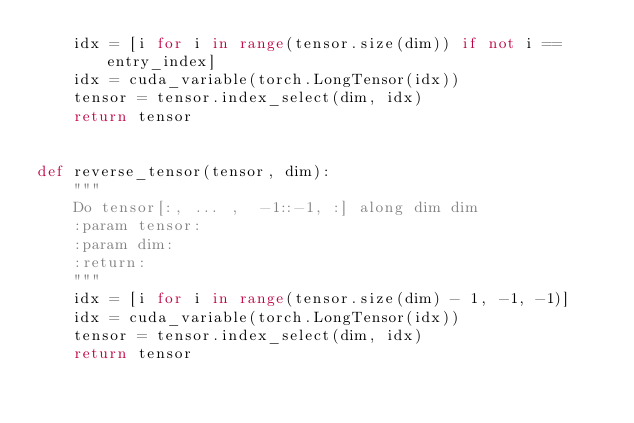<code> <loc_0><loc_0><loc_500><loc_500><_Python_>    idx = [i for i in range(tensor.size(dim)) if not i == entry_index]
    idx = cuda_variable(torch.LongTensor(idx))
    tensor = tensor.index_select(dim, idx)
    return tensor


def reverse_tensor(tensor, dim):
    """
    Do tensor[:, ... ,  -1::-1, :] along dim dim
    :param tensor:
    :param dim:
    :return:
    """
    idx = [i for i in range(tensor.size(dim) - 1, -1, -1)]
    idx = cuda_variable(torch.LongTensor(idx))
    tensor = tensor.index_select(dim, idx)
    return tensor
</code> 